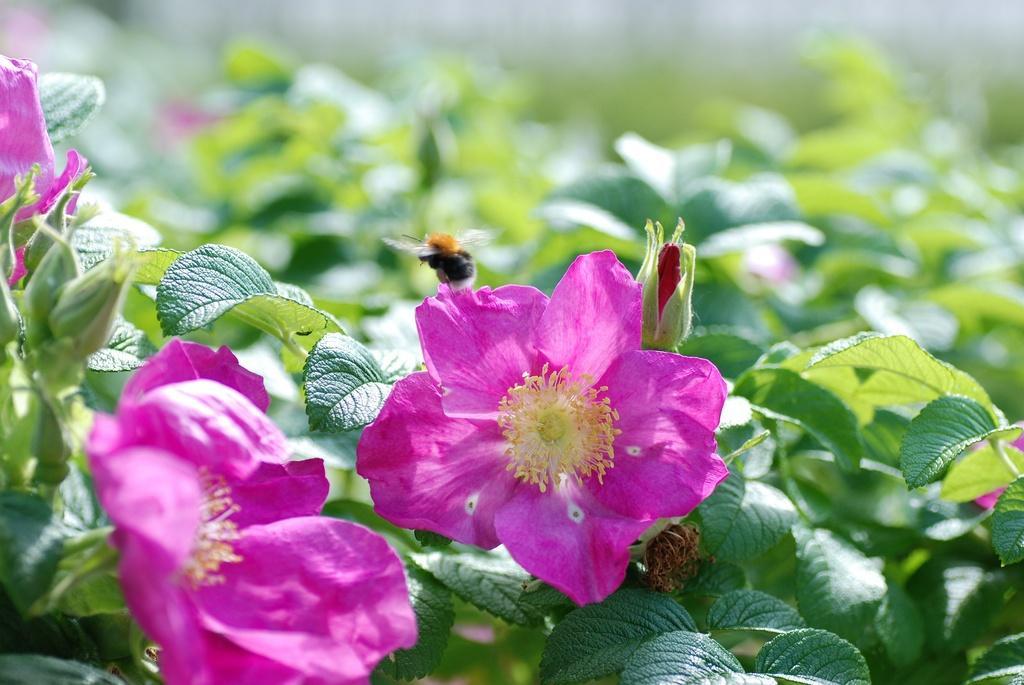Describe this image in one or two sentences. In this image I can see few pink colour flowers and number of green colour leaves in the front. I can also see an insect in the centre and in the background I can see few more leaves. I can also see this image is little bit blurry in the background. 